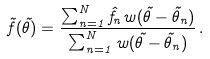<formula> <loc_0><loc_0><loc_500><loc_500>\tilde { f } ( \vec { \theta } ) = \frac { \sum _ { n = 1 } ^ { N } \hat { f } _ { n } w ( \vec { \theta } - \vec { \theta } _ { n } ) } { \sum _ { n = 1 } ^ { N } w ( \vec { \theta } - \vec { \theta } _ { n } ) } \, .</formula> 